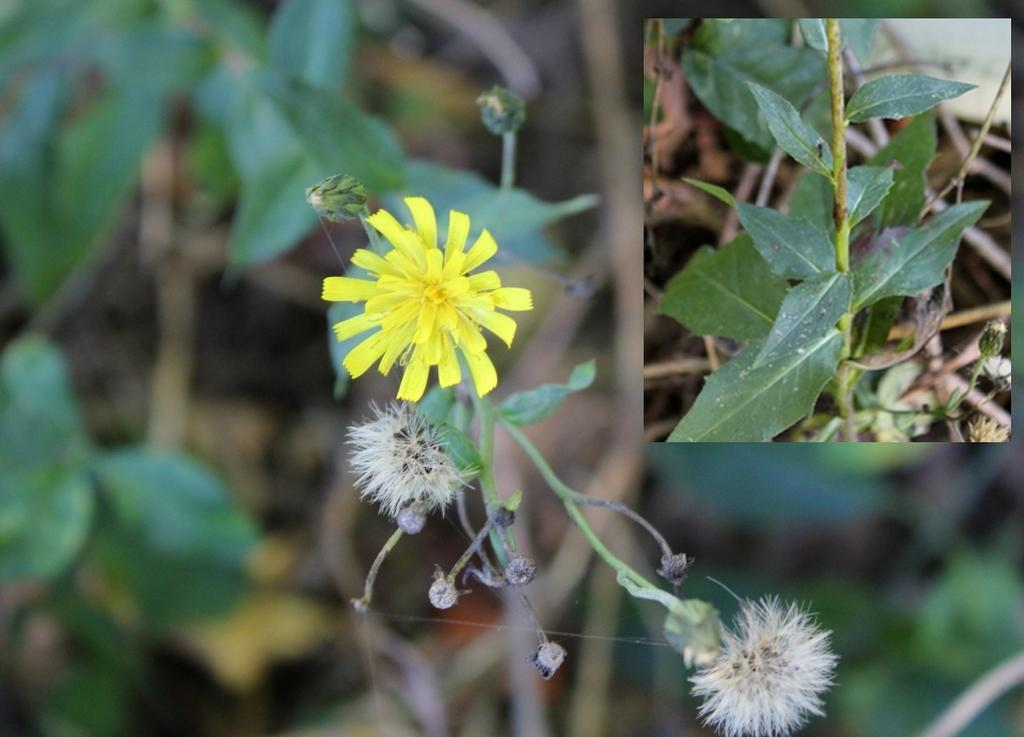What type of living organisms can be seen in the image? Plants and flowers are visible in the image. Can you describe the flowers in the image? There are flowers in the image, including a yellow flower in the center. What note is being played by the flowers in the image? There are no musical notes or instruments present in the image; it features plants and flowers. 